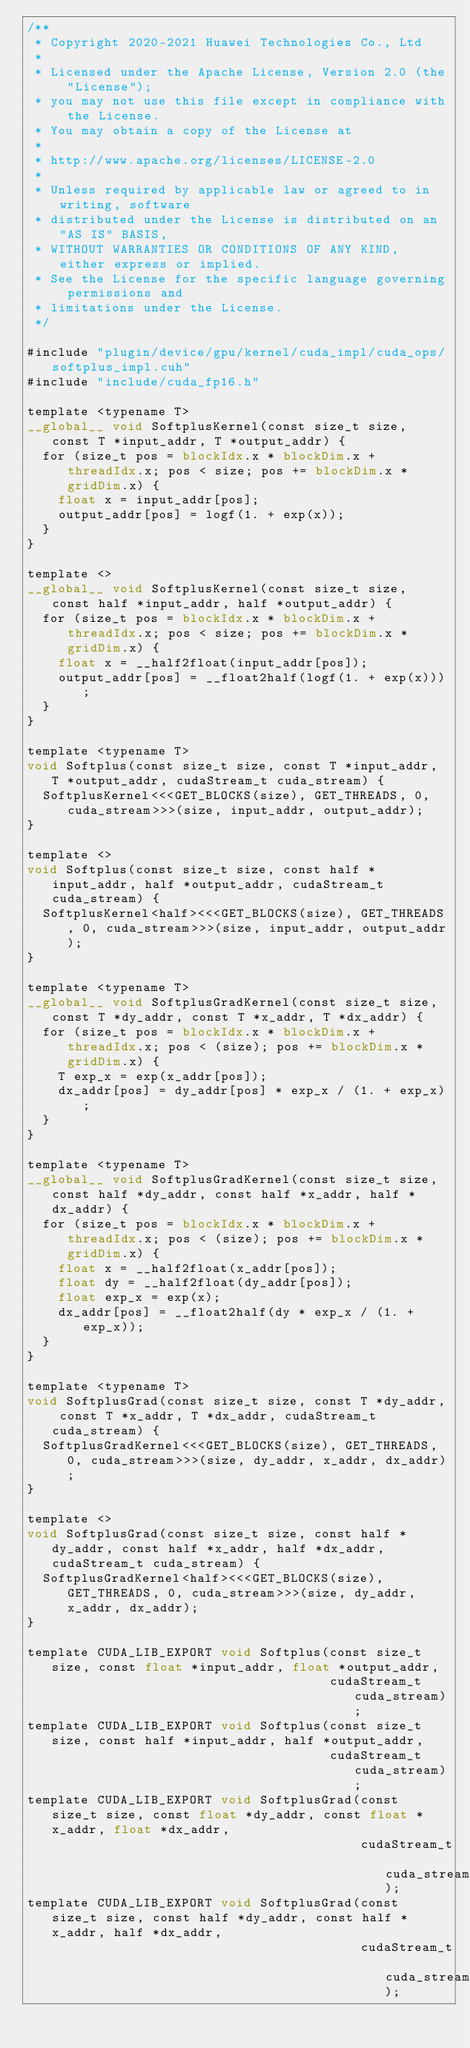Convert code to text. <code><loc_0><loc_0><loc_500><loc_500><_Cuda_>/**
 * Copyright 2020-2021 Huawei Technologies Co., Ltd
 *
 * Licensed under the Apache License, Version 2.0 (the "License");
 * you may not use this file except in compliance with the License.
 * You may obtain a copy of the License at
 *
 * http://www.apache.org/licenses/LICENSE-2.0
 *
 * Unless required by applicable law or agreed to in writing, software
 * distributed under the License is distributed on an "AS IS" BASIS,
 * WITHOUT WARRANTIES OR CONDITIONS OF ANY KIND, either express or implied.
 * See the License for the specific language governing permissions and
 * limitations under the License.
 */

#include "plugin/device/gpu/kernel/cuda_impl/cuda_ops/softplus_impl.cuh"
#include "include/cuda_fp16.h"

template <typename T>
__global__ void SoftplusKernel(const size_t size, const T *input_addr, T *output_addr) {
  for (size_t pos = blockIdx.x * blockDim.x + threadIdx.x; pos < size; pos += blockDim.x * gridDim.x) {
    float x = input_addr[pos];
    output_addr[pos] = logf(1. + exp(x));
  }
}

template <>
__global__ void SoftplusKernel(const size_t size, const half *input_addr, half *output_addr) {
  for (size_t pos = blockIdx.x * blockDim.x + threadIdx.x; pos < size; pos += blockDim.x * gridDim.x) {
    float x = __half2float(input_addr[pos]);
    output_addr[pos] = __float2half(logf(1. + exp(x)));
  }
}

template <typename T>
void Softplus(const size_t size, const T *input_addr, T *output_addr, cudaStream_t cuda_stream) {
  SoftplusKernel<<<GET_BLOCKS(size), GET_THREADS, 0, cuda_stream>>>(size, input_addr, output_addr);
}

template <>
void Softplus(const size_t size, const half *input_addr, half *output_addr, cudaStream_t cuda_stream) {
  SoftplusKernel<half><<<GET_BLOCKS(size), GET_THREADS, 0, cuda_stream>>>(size, input_addr, output_addr);
}

template <typename T>
__global__ void SoftplusGradKernel(const size_t size, const T *dy_addr, const T *x_addr, T *dx_addr) {
  for (size_t pos = blockIdx.x * blockDim.x + threadIdx.x; pos < (size); pos += blockDim.x * gridDim.x) {
    T exp_x = exp(x_addr[pos]);
    dx_addr[pos] = dy_addr[pos] * exp_x / (1. + exp_x);
  }
}

template <typename T>
__global__ void SoftplusGradKernel(const size_t size, const half *dy_addr, const half *x_addr, half *dx_addr) {
  for (size_t pos = blockIdx.x * blockDim.x + threadIdx.x; pos < (size); pos += blockDim.x * gridDim.x) {
    float x = __half2float(x_addr[pos]);
    float dy = __half2float(dy_addr[pos]);
    float exp_x = exp(x);
    dx_addr[pos] = __float2half(dy * exp_x / (1. + exp_x));
  }
}

template <typename T>
void SoftplusGrad(const size_t size, const T *dy_addr, const T *x_addr, T *dx_addr, cudaStream_t cuda_stream) {
  SoftplusGradKernel<<<GET_BLOCKS(size), GET_THREADS, 0, cuda_stream>>>(size, dy_addr, x_addr, dx_addr);
}

template <>
void SoftplusGrad(const size_t size, const half *dy_addr, const half *x_addr, half *dx_addr, cudaStream_t cuda_stream) {
  SoftplusGradKernel<half><<<GET_BLOCKS(size), GET_THREADS, 0, cuda_stream>>>(size, dy_addr, x_addr, dx_addr);
}

template CUDA_LIB_EXPORT void Softplus(const size_t size, const float *input_addr, float *output_addr,
                                       cudaStream_t cuda_stream);
template CUDA_LIB_EXPORT void Softplus(const size_t size, const half *input_addr, half *output_addr,
                                       cudaStream_t cuda_stream);
template CUDA_LIB_EXPORT void SoftplusGrad(const size_t size, const float *dy_addr, const float *x_addr, float *dx_addr,
                                           cudaStream_t cuda_stream);
template CUDA_LIB_EXPORT void SoftplusGrad(const size_t size, const half *dy_addr, const half *x_addr, half *dx_addr,
                                           cudaStream_t cuda_stream);
</code> 